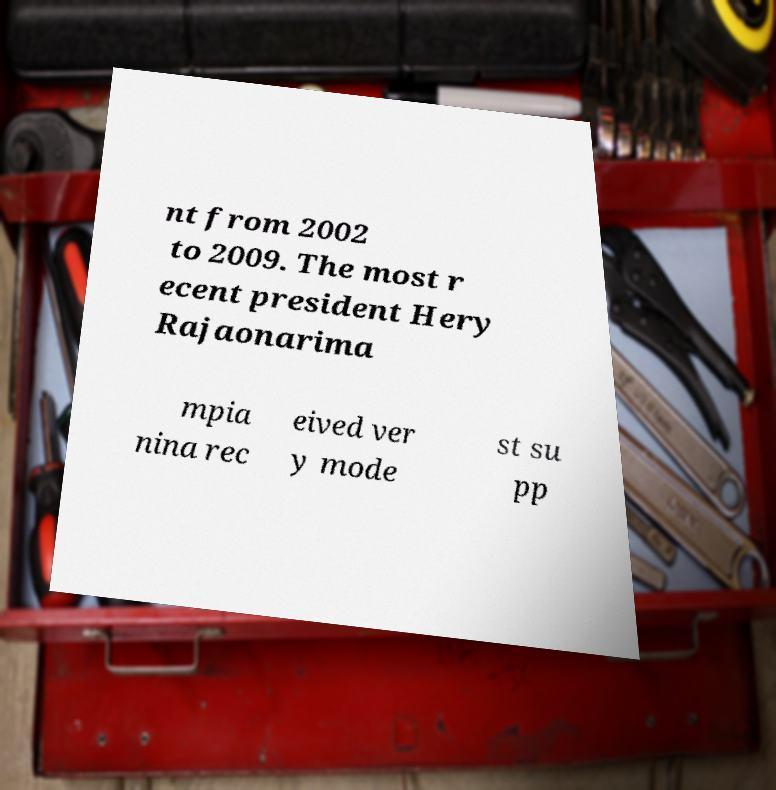Could you extract and type out the text from this image? nt from 2002 to 2009. The most r ecent president Hery Rajaonarima mpia nina rec eived ver y mode st su pp 